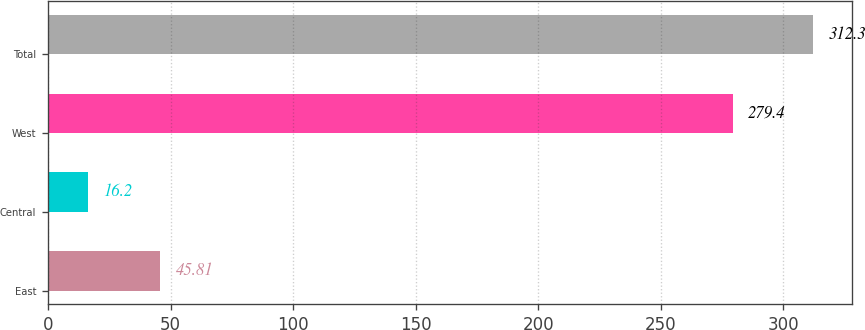<chart> <loc_0><loc_0><loc_500><loc_500><bar_chart><fcel>East<fcel>Central<fcel>West<fcel>Total<nl><fcel>45.81<fcel>16.2<fcel>279.4<fcel>312.3<nl></chart> 